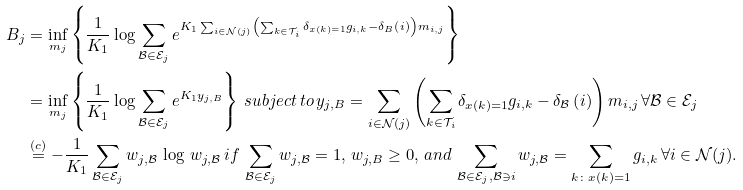Convert formula to latex. <formula><loc_0><loc_0><loc_500><loc_500>B _ { j } & = \inf _ { m _ { j } } \left \{ \frac { 1 } { K _ { 1 } } \log \sum _ { \mathcal { B } \in \mathcal { E } _ { j } } e ^ { K _ { 1 } \sum _ { i \in \mathcal { N } ( j ) } \left ( \sum _ { k \in \mathcal { T } _ { i } } \delta _ { x ( k ) = 1 } g _ { i , k } - \delta _ { B } \left ( i \right ) \right ) m _ { i , j } } \right \} \\ & = \inf _ { m _ { j } } \left \{ \frac { 1 } { K _ { 1 } } \log \sum _ { \mathcal { B } \in \mathcal { E } _ { j } } e ^ { K _ { 1 } y _ { j , B } } \right \} \, s u b j e c t \, t o \, y _ { j , B } = \sum _ { i \in \mathcal { N } ( j ) } \left ( \sum _ { k \in \mathcal { T } _ { i } } \delta _ { x ( k ) = 1 } g _ { i , k } - \delta _ { \mathcal { B } } \left ( i \right ) \right ) m _ { i , j } \, \forall \mathcal { B } \in \mathcal { E } _ { j } \\ & \stackrel { ( c ) } { = } - \frac { 1 } { K _ { 1 } } \sum _ { \mathcal { B } \in \mathcal { E } _ { j } } w _ { j , \mathcal { B } } \, \log \, w _ { j , \mathcal { B } } \, i f \, \sum _ { \mathcal { B } \in \mathcal { E } _ { j } } w _ { j , \mathcal { B } } = 1 , \, w _ { j , B } \geq 0 , \, a n d \, \sum _ { \mathcal { B } \in \mathcal { E } _ { j } , \mathcal { B } \ni i } w _ { j , \mathcal { B } } = \sum _ { k \colon x ( k ) = 1 } g _ { i , k } \, \forall i \in \mathcal { N } ( j ) .</formula> 